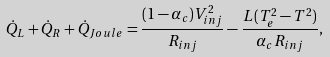<formula> <loc_0><loc_0><loc_500><loc_500>\dot { Q } _ { L } + \dot { Q } _ { R } + \dot { Q } _ { J o u l e } = \frac { ( 1 - \alpha _ { c } ) V _ { i n j } ^ { 2 } } { R _ { i n j } } - \frac { L ( T _ { e } ^ { 2 } - T ^ { 2 } ) } { \alpha _ { c } R _ { i n j } } ,</formula> 